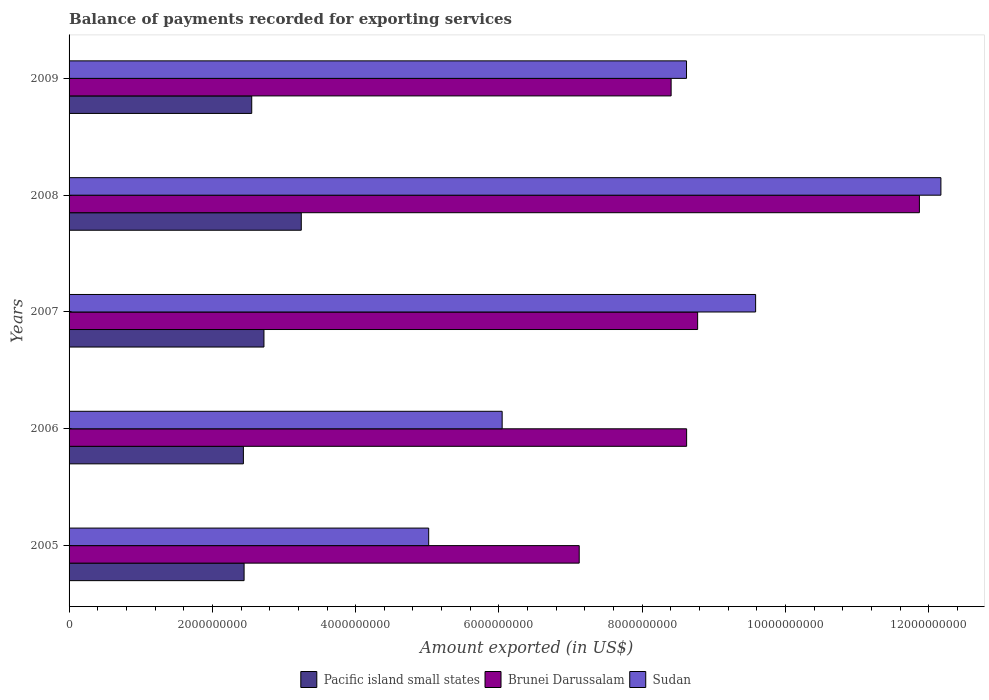How many different coloured bars are there?
Provide a short and direct response. 3. Are the number of bars per tick equal to the number of legend labels?
Give a very brief answer. Yes. What is the amount exported in Brunei Darussalam in 2005?
Your response must be concise. 7.12e+09. Across all years, what is the maximum amount exported in Pacific island small states?
Make the answer very short. 3.24e+09. Across all years, what is the minimum amount exported in Sudan?
Your answer should be very brief. 5.02e+09. In which year was the amount exported in Pacific island small states maximum?
Ensure brevity in your answer.  2008. What is the total amount exported in Pacific island small states in the graph?
Make the answer very short. 1.34e+1. What is the difference between the amount exported in Pacific island small states in 2007 and that in 2009?
Keep it short and to the point. 1.71e+08. What is the difference between the amount exported in Pacific island small states in 2006 and the amount exported in Brunei Darussalam in 2009?
Keep it short and to the point. -5.97e+09. What is the average amount exported in Sudan per year?
Make the answer very short. 8.29e+09. In the year 2008, what is the difference between the amount exported in Brunei Darussalam and amount exported in Sudan?
Ensure brevity in your answer.  -3.00e+08. In how many years, is the amount exported in Pacific island small states greater than 11200000000 US$?
Offer a terse response. 0. What is the ratio of the amount exported in Pacific island small states in 2006 to that in 2009?
Give a very brief answer. 0.95. Is the amount exported in Pacific island small states in 2005 less than that in 2006?
Ensure brevity in your answer.  No. Is the difference between the amount exported in Brunei Darussalam in 2007 and 2008 greater than the difference between the amount exported in Sudan in 2007 and 2008?
Your answer should be very brief. No. What is the difference between the highest and the second highest amount exported in Sudan?
Ensure brevity in your answer.  2.59e+09. What is the difference between the highest and the lowest amount exported in Sudan?
Keep it short and to the point. 7.15e+09. In how many years, is the amount exported in Pacific island small states greater than the average amount exported in Pacific island small states taken over all years?
Give a very brief answer. 2. Is the sum of the amount exported in Pacific island small states in 2005 and 2008 greater than the maximum amount exported in Sudan across all years?
Your answer should be very brief. No. What does the 3rd bar from the top in 2007 represents?
Offer a terse response. Pacific island small states. What does the 3rd bar from the bottom in 2008 represents?
Make the answer very short. Sudan. Is it the case that in every year, the sum of the amount exported in Brunei Darussalam and amount exported in Sudan is greater than the amount exported in Pacific island small states?
Provide a short and direct response. Yes. How many bars are there?
Make the answer very short. 15. How many years are there in the graph?
Make the answer very short. 5. Are the values on the major ticks of X-axis written in scientific E-notation?
Make the answer very short. No. How many legend labels are there?
Your response must be concise. 3. How are the legend labels stacked?
Offer a very short reply. Horizontal. What is the title of the graph?
Ensure brevity in your answer.  Balance of payments recorded for exporting services. What is the label or title of the X-axis?
Your response must be concise. Amount exported (in US$). What is the Amount exported (in US$) of Pacific island small states in 2005?
Offer a very short reply. 2.44e+09. What is the Amount exported (in US$) in Brunei Darussalam in 2005?
Make the answer very short. 7.12e+09. What is the Amount exported (in US$) in Sudan in 2005?
Provide a succinct answer. 5.02e+09. What is the Amount exported (in US$) in Pacific island small states in 2006?
Your answer should be very brief. 2.43e+09. What is the Amount exported (in US$) of Brunei Darussalam in 2006?
Ensure brevity in your answer.  8.62e+09. What is the Amount exported (in US$) in Sudan in 2006?
Provide a short and direct response. 6.04e+09. What is the Amount exported (in US$) of Pacific island small states in 2007?
Your answer should be very brief. 2.72e+09. What is the Amount exported (in US$) of Brunei Darussalam in 2007?
Offer a very short reply. 8.77e+09. What is the Amount exported (in US$) in Sudan in 2007?
Give a very brief answer. 9.58e+09. What is the Amount exported (in US$) of Pacific island small states in 2008?
Keep it short and to the point. 3.24e+09. What is the Amount exported (in US$) in Brunei Darussalam in 2008?
Your answer should be compact. 1.19e+1. What is the Amount exported (in US$) of Sudan in 2008?
Your response must be concise. 1.22e+1. What is the Amount exported (in US$) in Pacific island small states in 2009?
Offer a terse response. 2.55e+09. What is the Amount exported (in US$) of Brunei Darussalam in 2009?
Provide a short and direct response. 8.40e+09. What is the Amount exported (in US$) of Sudan in 2009?
Give a very brief answer. 8.62e+09. Across all years, what is the maximum Amount exported (in US$) of Pacific island small states?
Keep it short and to the point. 3.24e+09. Across all years, what is the maximum Amount exported (in US$) in Brunei Darussalam?
Provide a short and direct response. 1.19e+1. Across all years, what is the maximum Amount exported (in US$) of Sudan?
Your response must be concise. 1.22e+1. Across all years, what is the minimum Amount exported (in US$) in Pacific island small states?
Keep it short and to the point. 2.43e+09. Across all years, what is the minimum Amount exported (in US$) in Brunei Darussalam?
Your answer should be compact. 7.12e+09. Across all years, what is the minimum Amount exported (in US$) in Sudan?
Offer a very short reply. 5.02e+09. What is the total Amount exported (in US$) in Pacific island small states in the graph?
Make the answer very short. 1.34e+1. What is the total Amount exported (in US$) in Brunei Darussalam in the graph?
Your answer should be very brief. 4.48e+1. What is the total Amount exported (in US$) of Sudan in the graph?
Your answer should be very brief. 4.14e+1. What is the difference between the Amount exported (in US$) in Pacific island small states in 2005 and that in 2006?
Your response must be concise. 9.78e+06. What is the difference between the Amount exported (in US$) in Brunei Darussalam in 2005 and that in 2006?
Provide a succinct answer. -1.50e+09. What is the difference between the Amount exported (in US$) of Sudan in 2005 and that in 2006?
Offer a terse response. -1.03e+09. What is the difference between the Amount exported (in US$) in Pacific island small states in 2005 and that in 2007?
Make the answer very short. -2.77e+08. What is the difference between the Amount exported (in US$) in Brunei Darussalam in 2005 and that in 2007?
Offer a very short reply. -1.65e+09. What is the difference between the Amount exported (in US$) in Sudan in 2005 and that in 2007?
Make the answer very short. -4.56e+09. What is the difference between the Amount exported (in US$) of Pacific island small states in 2005 and that in 2008?
Make the answer very short. -7.98e+08. What is the difference between the Amount exported (in US$) in Brunei Darussalam in 2005 and that in 2008?
Offer a very short reply. -4.75e+09. What is the difference between the Amount exported (in US$) in Sudan in 2005 and that in 2008?
Offer a very short reply. -7.15e+09. What is the difference between the Amount exported (in US$) in Pacific island small states in 2005 and that in 2009?
Provide a succinct answer. -1.07e+08. What is the difference between the Amount exported (in US$) in Brunei Darussalam in 2005 and that in 2009?
Provide a short and direct response. -1.28e+09. What is the difference between the Amount exported (in US$) of Sudan in 2005 and that in 2009?
Your answer should be compact. -3.60e+09. What is the difference between the Amount exported (in US$) of Pacific island small states in 2006 and that in 2007?
Provide a short and direct response. -2.87e+08. What is the difference between the Amount exported (in US$) of Brunei Darussalam in 2006 and that in 2007?
Your answer should be very brief. -1.54e+08. What is the difference between the Amount exported (in US$) of Sudan in 2006 and that in 2007?
Keep it short and to the point. -3.54e+09. What is the difference between the Amount exported (in US$) in Pacific island small states in 2006 and that in 2008?
Your answer should be compact. -8.08e+08. What is the difference between the Amount exported (in US$) in Brunei Darussalam in 2006 and that in 2008?
Offer a very short reply. -3.25e+09. What is the difference between the Amount exported (in US$) in Sudan in 2006 and that in 2008?
Provide a succinct answer. -6.12e+09. What is the difference between the Amount exported (in US$) in Pacific island small states in 2006 and that in 2009?
Your response must be concise. -1.16e+08. What is the difference between the Amount exported (in US$) in Brunei Darussalam in 2006 and that in 2009?
Offer a very short reply. 2.16e+08. What is the difference between the Amount exported (in US$) in Sudan in 2006 and that in 2009?
Keep it short and to the point. -2.57e+09. What is the difference between the Amount exported (in US$) in Pacific island small states in 2007 and that in 2008?
Provide a succinct answer. -5.21e+08. What is the difference between the Amount exported (in US$) in Brunei Darussalam in 2007 and that in 2008?
Your answer should be very brief. -3.10e+09. What is the difference between the Amount exported (in US$) in Sudan in 2007 and that in 2008?
Provide a short and direct response. -2.59e+09. What is the difference between the Amount exported (in US$) of Pacific island small states in 2007 and that in 2009?
Make the answer very short. 1.71e+08. What is the difference between the Amount exported (in US$) in Brunei Darussalam in 2007 and that in 2009?
Your answer should be very brief. 3.70e+08. What is the difference between the Amount exported (in US$) in Sudan in 2007 and that in 2009?
Your answer should be compact. 9.65e+08. What is the difference between the Amount exported (in US$) of Pacific island small states in 2008 and that in 2009?
Ensure brevity in your answer.  6.92e+08. What is the difference between the Amount exported (in US$) of Brunei Darussalam in 2008 and that in 2009?
Your answer should be very brief. 3.47e+09. What is the difference between the Amount exported (in US$) of Sudan in 2008 and that in 2009?
Make the answer very short. 3.55e+09. What is the difference between the Amount exported (in US$) in Pacific island small states in 2005 and the Amount exported (in US$) in Brunei Darussalam in 2006?
Make the answer very short. -6.18e+09. What is the difference between the Amount exported (in US$) of Pacific island small states in 2005 and the Amount exported (in US$) of Sudan in 2006?
Give a very brief answer. -3.60e+09. What is the difference between the Amount exported (in US$) of Brunei Darussalam in 2005 and the Amount exported (in US$) of Sudan in 2006?
Offer a terse response. 1.08e+09. What is the difference between the Amount exported (in US$) of Pacific island small states in 2005 and the Amount exported (in US$) of Brunei Darussalam in 2007?
Provide a succinct answer. -6.33e+09. What is the difference between the Amount exported (in US$) in Pacific island small states in 2005 and the Amount exported (in US$) in Sudan in 2007?
Your answer should be compact. -7.14e+09. What is the difference between the Amount exported (in US$) in Brunei Darussalam in 2005 and the Amount exported (in US$) in Sudan in 2007?
Your answer should be compact. -2.46e+09. What is the difference between the Amount exported (in US$) of Pacific island small states in 2005 and the Amount exported (in US$) of Brunei Darussalam in 2008?
Ensure brevity in your answer.  -9.43e+09. What is the difference between the Amount exported (in US$) of Pacific island small states in 2005 and the Amount exported (in US$) of Sudan in 2008?
Your response must be concise. -9.73e+09. What is the difference between the Amount exported (in US$) in Brunei Darussalam in 2005 and the Amount exported (in US$) in Sudan in 2008?
Keep it short and to the point. -5.05e+09. What is the difference between the Amount exported (in US$) in Pacific island small states in 2005 and the Amount exported (in US$) in Brunei Darussalam in 2009?
Make the answer very short. -5.96e+09. What is the difference between the Amount exported (in US$) of Pacific island small states in 2005 and the Amount exported (in US$) of Sudan in 2009?
Offer a very short reply. -6.17e+09. What is the difference between the Amount exported (in US$) in Brunei Darussalam in 2005 and the Amount exported (in US$) in Sudan in 2009?
Your response must be concise. -1.50e+09. What is the difference between the Amount exported (in US$) of Pacific island small states in 2006 and the Amount exported (in US$) of Brunei Darussalam in 2007?
Provide a succinct answer. -6.34e+09. What is the difference between the Amount exported (in US$) of Pacific island small states in 2006 and the Amount exported (in US$) of Sudan in 2007?
Make the answer very short. -7.15e+09. What is the difference between the Amount exported (in US$) in Brunei Darussalam in 2006 and the Amount exported (in US$) in Sudan in 2007?
Your response must be concise. -9.63e+08. What is the difference between the Amount exported (in US$) of Pacific island small states in 2006 and the Amount exported (in US$) of Brunei Darussalam in 2008?
Ensure brevity in your answer.  -9.44e+09. What is the difference between the Amount exported (in US$) in Pacific island small states in 2006 and the Amount exported (in US$) in Sudan in 2008?
Your response must be concise. -9.74e+09. What is the difference between the Amount exported (in US$) in Brunei Darussalam in 2006 and the Amount exported (in US$) in Sudan in 2008?
Offer a terse response. -3.55e+09. What is the difference between the Amount exported (in US$) in Pacific island small states in 2006 and the Amount exported (in US$) in Brunei Darussalam in 2009?
Provide a succinct answer. -5.97e+09. What is the difference between the Amount exported (in US$) of Pacific island small states in 2006 and the Amount exported (in US$) of Sudan in 2009?
Give a very brief answer. -6.18e+09. What is the difference between the Amount exported (in US$) in Brunei Darussalam in 2006 and the Amount exported (in US$) in Sudan in 2009?
Provide a short and direct response. 1.53e+06. What is the difference between the Amount exported (in US$) in Pacific island small states in 2007 and the Amount exported (in US$) in Brunei Darussalam in 2008?
Offer a very short reply. -9.15e+09. What is the difference between the Amount exported (in US$) in Pacific island small states in 2007 and the Amount exported (in US$) in Sudan in 2008?
Your answer should be very brief. -9.45e+09. What is the difference between the Amount exported (in US$) in Brunei Darussalam in 2007 and the Amount exported (in US$) in Sudan in 2008?
Make the answer very short. -3.40e+09. What is the difference between the Amount exported (in US$) in Pacific island small states in 2007 and the Amount exported (in US$) in Brunei Darussalam in 2009?
Offer a very short reply. -5.68e+09. What is the difference between the Amount exported (in US$) of Pacific island small states in 2007 and the Amount exported (in US$) of Sudan in 2009?
Offer a terse response. -5.90e+09. What is the difference between the Amount exported (in US$) of Brunei Darussalam in 2007 and the Amount exported (in US$) of Sudan in 2009?
Your answer should be compact. 1.55e+08. What is the difference between the Amount exported (in US$) of Pacific island small states in 2008 and the Amount exported (in US$) of Brunei Darussalam in 2009?
Ensure brevity in your answer.  -5.16e+09. What is the difference between the Amount exported (in US$) in Pacific island small states in 2008 and the Amount exported (in US$) in Sudan in 2009?
Provide a succinct answer. -5.38e+09. What is the difference between the Amount exported (in US$) in Brunei Darussalam in 2008 and the Amount exported (in US$) in Sudan in 2009?
Offer a terse response. 3.25e+09. What is the average Amount exported (in US$) of Pacific island small states per year?
Your response must be concise. 2.68e+09. What is the average Amount exported (in US$) of Brunei Darussalam per year?
Offer a terse response. 8.96e+09. What is the average Amount exported (in US$) in Sudan per year?
Your response must be concise. 8.29e+09. In the year 2005, what is the difference between the Amount exported (in US$) of Pacific island small states and Amount exported (in US$) of Brunei Darussalam?
Ensure brevity in your answer.  -4.68e+09. In the year 2005, what is the difference between the Amount exported (in US$) in Pacific island small states and Amount exported (in US$) in Sudan?
Offer a terse response. -2.58e+09. In the year 2005, what is the difference between the Amount exported (in US$) in Brunei Darussalam and Amount exported (in US$) in Sudan?
Make the answer very short. 2.10e+09. In the year 2006, what is the difference between the Amount exported (in US$) of Pacific island small states and Amount exported (in US$) of Brunei Darussalam?
Your response must be concise. -6.19e+09. In the year 2006, what is the difference between the Amount exported (in US$) of Pacific island small states and Amount exported (in US$) of Sudan?
Provide a short and direct response. -3.61e+09. In the year 2006, what is the difference between the Amount exported (in US$) of Brunei Darussalam and Amount exported (in US$) of Sudan?
Provide a succinct answer. 2.57e+09. In the year 2007, what is the difference between the Amount exported (in US$) of Pacific island small states and Amount exported (in US$) of Brunei Darussalam?
Give a very brief answer. -6.05e+09. In the year 2007, what is the difference between the Amount exported (in US$) of Pacific island small states and Amount exported (in US$) of Sudan?
Provide a short and direct response. -6.86e+09. In the year 2007, what is the difference between the Amount exported (in US$) in Brunei Darussalam and Amount exported (in US$) in Sudan?
Your answer should be very brief. -8.09e+08. In the year 2008, what is the difference between the Amount exported (in US$) of Pacific island small states and Amount exported (in US$) of Brunei Darussalam?
Your answer should be very brief. -8.63e+09. In the year 2008, what is the difference between the Amount exported (in US$) in Pacific island small states and Amount exported (in US$) in Sudan?
Your response must be concise. -8.93e+09. In the year 2008, what is the difference between the Amount exported (in US$) of Brunei Darussalam and Amount exported (in US$) of Sudan?
Offer a very short reply. -3.00e+08. In the year 2009, what is the difference between the Amount exported (in US$) of Pacific island small states and Amount exported (in US$) of Brunei Darussalam?
Offer a terse response. -5.85e+09. In the year 2009, what is the difference between the Amount exported (in US$) in Pacific island small states and Amount exported (in US$) in Sudan?
Offer a terse response. -6.07e+09. In the year 2009, what is the difference between the Amount exported (in US$) of Brunei Darussalam and Amount exported (in US$) of Sudan?
Your response must be concise. -2.15e+08. What is the ratio of the Amount exported (in US$) of Pacific island small states in 2005 to that in 2006?
Provide a short and direct response. 1. What is the ratio of the Amount exported (in US$) of Brunei Darussalam in 2005 to that in 2006?
Provide a succinct answer. 0.83. What is the ratio of the Amount exported (in US$) of Sudan in 2005 to that in 2006?
Offer a terse response. 0.83. What is the ratio of the Amount exported (in US$) of Pacific island small states in 2005 to that in 2007?
Your answer should be compact. 0.9. What is the ratio of the Amount exported (in US$) of Brunei Darussalam in 2005 to that in 2007?
Provide a short and direct response. 0.81. What is the ratio of the Amount exported (in US$) in Sudan in 2005 to that in 2007?
Your response must be concise. 0.52. What is the ratio of the Amount exported (in US$) in Pacific island small states in 2005 to that in 2008?
Your response must be concise. 0.75. What is the ratio of the Amount exported (in US$) in Brunei Darussalam in 2005 to that in 2008?
Keep it short and to the point. 0.6. What is the ratio of the Amount exported (in US$) in Sudan in 2005 to that in 2008?
Your answer should be compact. 0.41. What is the ratio of the Amount exported (in US$) of Pacific island small states in 2005 to that in 2009?
Provide a short and direct response. 0.96. What is the ratio of the Amount exported (in US$) of Brunei Darussalam in 2005 to that in 2009?
Your answer should be very brief. 0.85. What is the ratio of the Amount exported (in US$) in Sudan in 2005 to that in 2009?
Provide a short and direct response. 0.58. What is the ratio of the Amount exported (in US$) in Pacific island small states in 2006 to that in 2007?
Offer a terse response. 0.89. What is the ratio of the Amount exported (in US$) of Brunei Darussalam in 2006 to that in 2007?
Give a very brief answer. 0.98. What is the ratio of the Amount exported (in US$) of Sudan in 2006 to that in 2007?
Your response must be concise. 0.63. What is the ratio of the Amount exported (in US$) of Pacific island small states in 2006 to that in 2008?
Your response must be concise. 0.75. What is the ratio of the Amount exported (in US$) in Brunei Darussalam in 2006 to that in 2008?
Provide a short and direct response. 0.73. What is the ratio of the Amount exported (in US$) of Sudan in 2006 to that in 2008?
Your answer should be compact. 0.5. What is the ratio of the Amount exported (in US$) of Pacific island small states in 2006 to that in 2009?
Offer a very short reply. 0.95. What is the ratio of the Amount exported (in US$) in Brunei Darussalam in 2006 to that in 2009?
Provide a short and direct response. 1.03. What is the ratio of the Amount exported (in US$) in Sudan in 2006 to that in 2009?
Ensure brevity in your answer.  0.7. What is the ratio of the Amount exported (in US$) in Pacific island small states in 2007 to that in 2008?
Keep it short and to the point. 0.84. What is the ratio of the Amount exported (in US$) in Brunei Darussalam in 2007 to that in 2008?
Your response must be concise. 0.74. What is the ratio of the Amount exported (in US$) in Sudan in 2007 to that in 2008?
Ensure brevity in your answer.  0.79. What is the ratio of the Amount exported (in US$) in Pacific island small states in 2007 to that in 2009?
Your answer should be compact. 1.07. What is the ratio of the Amount exported (in US$) in Brunei Darussalam in 2007 to that in 2009?
Your response must be concise. 1.04. What is the ratio of the Amount exported (in US$) in Sudan in 2007 to that in 2009?
Ensure brevity in your answer.  1.11. What is the ratio of the Amount exported (in US$) in Pacific island small states in 2008 to that in 2009?
Your response must be concise. 1.27. What is the ratio of the Amount exported (in US$) in Brunei Darussalam in 2008 to that in 2009?
Offer a very short reply. 1.41. What is the ratio of the Amount exported (in US$) in Sudan in 2008 to that in 2009?
Provide a short and direct response. 1.41. What is the difference between the highest and the second highest Amount exported (in US$) in Pacific island small states?
Ensure brevity in your answer.  5.21e+08. What is the difference between the highest and the second highest Amount exported (in US$) of Brunei Darussalam?
Provide a succinct answer. 3.10e+09. What is the difference between the highest and the second highest Amount exported (in US$) in Sudan?
Keep it short and to the point. 2.59e+09. What is the difference between the highest and the lowest Amount exported (in US$) in Pacific island small states?
Offer a very short reply. 8.08e+08. What is the difference between the highest and the lowest Amount exported (in US$) of Brunei Darussalam?
Your answer should be compact. 4.75e+09. What is the difference between the highest and the lowest Amount exported (in US$) of Sudan?
Your answer should be compact. 7.15e+09. 